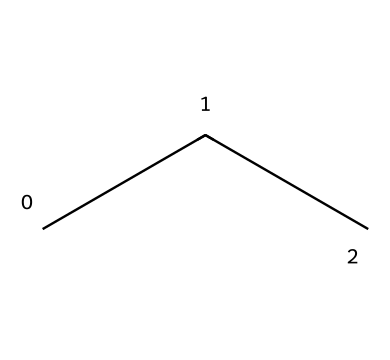What is the molecular formula of this chemical? The structural formula represented by the SMILES notation "CCC" indicates a straight-chain alkane with three carbon atoms and corresponding hydrogens. The molecular formula combines the number of carbon and hydrogen atoms to give C3H8.
Answer: C3H8 How many carbon atoms are in the structure? The SMILES notation "CCC" shows three contiguous 'C' characters, each representing a carbon atom. Thus, there are three carbon atoms in total.
Answer: 3 How many hydrogen atoms are there in propane? When propane has three carbon atoms, each carbon is bonded to enough hydrogen atoms to fill its tetravalent state. The total for propane will be 8 (2 for the terminal carbons and 3 for the central carbon).
Answer: 8 Is this compound a hydrocarbon? This structure contains only carbon and hydrogen atoms without any other elements, qualifying it as a hydrocarbon.
Answer: Yes What type of refrigerant is propane considered? Propane, represented by this chemical structure, is known as a natural refrigerant due to its low environmental impact and efficiency.
Answer: Natural What are the implications of using propane in small appliances? Using propane as a refrigerant can contribute to lower greenhouse gas emissions and reduced energy consumption, making it a more sustainable option compared to traditional refrigerants.
Answer: Sustainable What kind of bonds can be found in this structural formula? Propane is an alkane, which contains single covalent bonds connecting the carbon atoms to each other and to hydrogen atoms, indicating it has only sigma bonds.
Answer: Sigma 